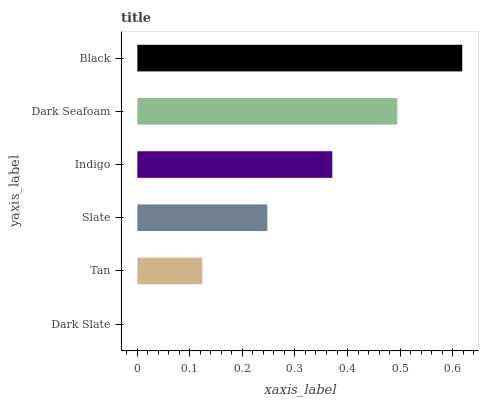Is Dark Slate the minimum?
Answer yes or no. Yes. Is Black the maximum?
Answer yes or no. Yes. Is Tan the minimum?
Answer yes or no. No. Is Tan the maximum?
Answer yes or no. No. Is Tan greater than Dark Slate?
Answer yes or no. Yes. Is Dark Slate less than Tan?
Answer yes or no. Yes. Is Dark Slate greater than Tan?
Answer yes or no. No. Is Tan less than Dark Slate?
Answer yes or no. No. Is Indigo the high median?
Answer yes or no. Yes. Is Slate the low median?
Answer yes or no. Yes. Is Black the high median?
Answer yes or no. No. Is Tan the low median?
Answer yes or no. No. 